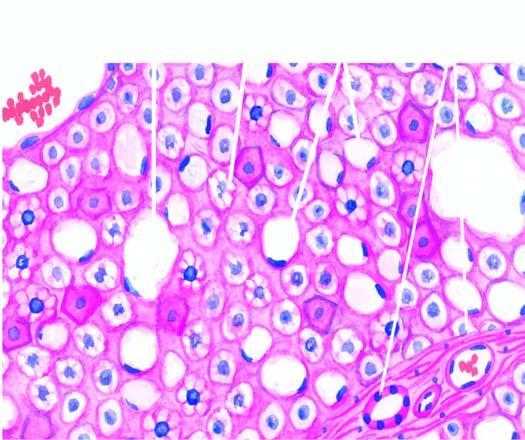re many of the hepatocytes distended with large fat vacuoles pushing the nuclei to the periphery macrovesicles, while others show multiple small vacuoles in the cytoplasm microvesicles?
Answer the question using a single word or phrase. Yes 